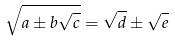<formula> <loc_0><loc_0><loc_500><loc_500>\sqrt { a \pm b \sqrt { c } } = \sqrt { d } \pm \sqrt { e }</formula> 